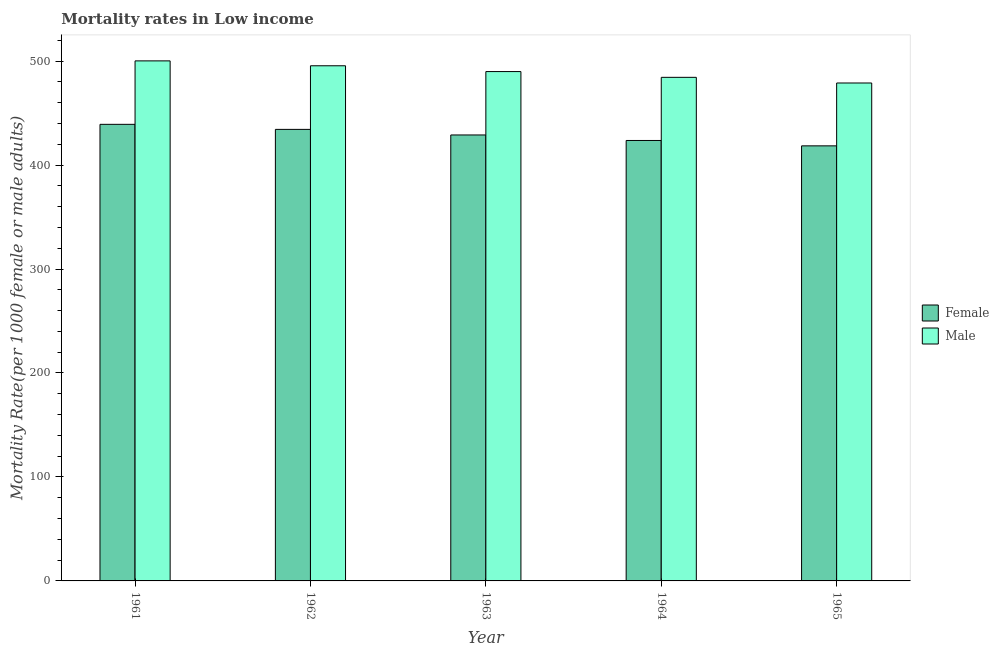How many different coloured bars are there?
Your response must be concise. 2. How many groups of bars are there?
Provide a succinct answer. 5. Are the number of bars per tick equal to the number of legend labels?
Your answer should be very brief. Yes. Are the number of bars on each tick of the X-axis equal?
Your answer should be very brief. Yes. How many bars are there on the 4th tick from the right?
Your response must be concise. 2. What is the female mortality rate in 1963?
Provide a short and direct response. 428.93. Across all years, what is the maximum male mortality rate?
Give a very brief answer. 500.19. Across all years, what is the minimum female mortality rate?
Offer a terse response. 418.46. In which year was the male mortality rate minimum?
Your response must be concise. 1965. What is the total male mortality rate in the graph?
Your answer should be compact. 2448.88. What is the difference between the male mortality rate in 1963 and that in 1964?
Make the answer very short. 5.54. What is the difference between the female mortality rate in 1963 and the male mortality rate in 1964?
Your response must be concise. 5.3. What is the average female mortality rate per year?
Offer a terse response. 428.89. In the year 1961, what is the difference between the female mortality rate and male mortality rate?
Make the answer very short. 0. In how many years, is the male mortality rate greater than 260?
Make the answer very short. 5. What is the ratio of the female mortality rate in 1961 to that in 1962?
Make the answer very short. 1.01. Is the male mortality rate in 1962 less than that in 1963?
Your answer should be very brief. No. What is the difference between the highest and the second highest male mortality rate?
Offer a terse response. 4.71. What is the difference between the highest and the lowest female mortality rate?
Offer a very short reply. 20.69. What does the 1st bar from the right in 1962 represents?
Provide a succinct answer. Male. How many bars are there?
Give a very brief answer. 10. What is the difference between two consecutive major ticks on the Y-axis?
Your response must be concise. 100. Does the graph contain grids?
Your answer should be very brief. No. How many legend labels are there?
Keep it short and to the point. 2. What is the title of the graph?
Your answer should be very brief. Mortality rates in Low income. Does "Frequency of shipment arrival" appear as one of the legend labels in the graph?
Keep it short and to the point. No. What is the label or title of the Y-axis?
Provide a short and direct response. Mortality Rate(per 1000 female or male adults). What is the Mortality Rate(per 1000 female or male adults) of Female in 1961?
Your answer should be compact. 439.15. What is the Mortality Rate(per 1000 female or male adults) of Male in 1961?
Provide a succinct answer. 500.19. What is the Mortality Rate(per 1000 female or male adults) in Female in 1962?
Provide a short and direct response. 434.3. What is the Mortality Rate(per 1000 female or male adults) in Male in 1962?
Keep it short and to the point. 495.49. What is the Mortality Rate(per 1000 female or male adults) in Female in 1963?
Keep it short and to the point. 428.93. What is the Mortality Rate(per 1000 female or male adults) of Male in 1963?
Your answer should be compact. 489.91. What is the Mortality Rate(per 1000 female or male adults) of Female in 1964?
Your response must be concise. 423.63. What is the Mortality Rate(per 1000 female or male adults) in Male in 1964?
Your answer should be very brief. 484.37. What is the Mortality Rate(per 1000 female or male adults) of Female in 1965?
Provide a succinct answer. 418.46. What is the Mortality Rate(per 1000 female or male adults) in Male in 1965?
Your answer should be compact. 478.92. Across all years, what is the maximum Mortality Rate(per 1000 female or male adults) of Female?
Your answer should be very brief. 439.15. Across all years, what is the maximum Mortality Rate(per 1000 female or male adults) of Male?
Offer a terse response. 500.19. Across all years, what is the minimum Mortality Rate(per 1000 female or male adults) in Female?
Ensure brevity in your answer.  418.46. Across all years, what is the minimum Mortality Rate(per 1000 female or male adults) of Male?
Provide a succinct answer. 478.92. What is the total Mortality Rate(per 1000 female or male adults) in Female in the graph?
Your response must be concise. 2144.47. What is the total Mortality Rate(per 1000 female or male adults) of Male in the graph?
Offer a terse response. 2448.88. What is the difference between the Mortality Rate(per 1000 female or male adults) in Female in 1961 and that in 1962?
Make the answer very short. 4.85. What is the difference between the Mortality Rate(per 1000 female or male adults) of Male in 1961 and that in 1962?
Give a very brief answer. 4.71. What is the difference between the Mortality Rate(per 1000 female or male adults) of Female in 1961 and that in 1963?
Make the answer very short. 10.22. What is the difference between the Mortality Rate(per 1000 female or male adults) of Male in 1961 and that in 1963?
Ensure brevity in your answer.  10.28. What is the difference between the Mortality Rate(per 1000 female or male adults) of Female in 1961 and that in 1964?
Provide a short and direct response. 15.52. What is the difference between the Mortality Rate(per 1000 female or male adults) of Male in 1961 and that in 1964?
Your response must be concise. 15.82. What is the difference between the Mortality Rate(per 1000 female or male adults) of Female in 1961 and that in 1965?
Make the answer very short. 20.69. What is the difference between the Mortality Rate(per 1000 female or male adults) of Male in 1961 and that in 1965?
Offer a very short reply. 21.27. What is the difference between the Mortality Rate(per 1000 female or male adults) in Female in 1962 and that in 1963?
Your answer should be compact. 5.37. What is the difference between the Mortality Rate(per 1000 female or male adults) of Male in 1962 and that in 1963?
Your answer should be compact. 5.58. What is the difference between the Mortality Rate(per 1000 female or male adults) in Female in 1962 and that in 1964?
Ensure brevity in your answer.  10.67. What is the difference between the Mortality Rate(per 1000 female or male adults) of Male in 1962 and that in 1964?
Make the answer very short. 11.12. What is the difference between the Mortality Rate(per 1000 female or male adults) in Female in 1962 and that in 1965?
Your answer should be compact. 15.84. What is the difference between the Mortality Rate(per 1000 female or male adults) of Male in 1962 and that in 1965?
Provide a short and direct response. 16.57. What is the difference between the Mortality Rate(per 1000 female or male adults) in Female in 1963 and that in 1964?
Keep it short and to the point. 5.3. What is the difference between the Mortality Rate(per 1000 female or male adults) of Male in 1963 and that in 1964?
Ensure brevity in your answer.  5.54. What is the difference between the Mortality Rate(per 1000 female or male adults) of Female in 1963 and that in 1965?
Give a very brief answer. 10.48. What is the difference between the Mortality Rate(per 1000 female or male adults) in Male in 1963 and that in 1965?
Keep it short and to the point. 10.99. What is the difference between the Mortality Rate(per 1000 female or male adults) in Female in 1964 and that in 1965?
Your answer should be compact. 5.17. What is the difference between the Mortality Rate(per 1000 female or male adults) in Male in 1964 and that in 1965?
Your response must be concise. 5.45. What is the difference between the Mortality Rate(per 1000 female or male adults) in Female in 1961 and the Mortality Rate(per 1000 female or male adults) in Male in 1962?
Your answer should be very brief. -56.33. What is the difference between the Mortality Rate(per 1000 female or male adults) in Female in 1961 and the Mortality Rate(per 1000 female or male adults) in Male in 1963?
Offer a terse response. -50.76. What is the difference between the Mortality Rate(per 1000 female or male adults) of Female in 1961 and the Mortality Rate(per 1000 female or male adults) of Male in 1964?
Give a very brief answer. -45.22. What is the difference between the Mortality Rate(per 1000 female or male adults) in Female in 1961 and the Mortality Rate(per 1000 female or male adults) in Male in 1965?
Offer a terse response. -39.77. What is the difference between the Mortality Rate(per 1000 female or male adults) of Female in 1962 and the Mortality Rate(per 1000 female or male adults) of Male in 1963?
Offer a terse response. -55.61. What is the difference between the Mortality Rate(per 1000 female or male adults) in Female in 1962 and the Mortality Rate(per 1000 female or male adults) in Male in 1964?
Offer a terse response. -50.07. What is the difference between the Mortality Rate(per 1000 female or male adults) in Female in 1962 and the Mortality Rate(per 1000 female or male adults) in Male in 1965?
Offer a terse response. -44.62. What is the difference between the Mortality Rate(per 1000 female or male adults) in Female in 1963 and the Mortality Rate(per 1000 female or male adults) in Male in 1964?
Offer a terse response. -55.44. What is the difference between the Mortality Rate(per 1000 female or male adults) of Female in 1963 and the Mortality Rate(per 1000 female or male adults) of Male in 1965?
Your response must be concise. -49.99. What is the difference between the Mortality Rate(per 1000 female or male adults) of Female in 1964 and the Mortality Rate(per 1000 female or male adults) of Male in 1965?
Give a very brief answer. -55.29. What is the average Mortality Rate(per 1000 female or male adults) in Female per year?
Your answer should be very brief. 428.89. What is the average Mortality Rate(per 1000 female or male adults) in Male per year?
Keep it short and to the point. 489.78. In the year 1961, what is the difference between the Mortality Rate(per 1000 female or male adults) of Female and Mortality Rate(per 1000 female or male adults) of Male?
Ensure brevity in your answer.  -61.04. In the year 1962, what is the difference between the Mortality Rate(per 1000 female or male adults) of Female and Mortality Rate(per 1000 female or male adults) of Male?
Provide a short and direct response. -61.18. In the year 1963, what is the difference between the Mortality Rate(per 1000 female or male adults) in Female and Mortality Rate(per 1000 female or male adults) in Male?
Provide a succinct answer. -60.98. In the year 1964, what is the difference between the Mortality Rate(per 1000 female or male adults) in Female and Mortality Rate(per 1000 female or male adults) in Male?
Your response must be concise. -60.74. In the year 1965, what is the difference between the Mortality Rate(per 1000 female or male adults) in Female and Mortality Rate(per 1000 female or male adults) in Male?
Offer a very short reply. -60.46. What is the ratio of the Mortality Rate(per 1000 female or male adults) in Female in 1961 to that in 1962?
Ensure brevity in your answer.  1.01. What is the ratio of the Mortality Rate(per 1000 female or male adults) in Male in 1961 to that in 1962?
Provide a short and direct response. 1.01. What is the ratio of the Mortality Rate(per 1000 female or male adults) of Female in 1961 to that in 1963?
Give a very brief answer. 1.02. What is the ratio of the Mortality Rate(per 1000 female or male adults) in Female in 1961 to that in 1964?
Ensure brevity in your answer.  1.04. What is the ratio of the Mortality Rate(per 1000 female or male adults) in Male in 1961 to that in 1964?
Your answer should be compact. 1.03. What is the ratio of the Mortality Rate(per 1000 female or male adults) in Female in 1961 to that in 1965?
Provide a short and direct response. 1.05. What is the ratio of the Mortality Rate(per 1000 female or male adults) of Male in 1961 to that in 1965?
Make the answer very short. 1.04. What is the ratio of the Mortality Rate(per 1000 female or male adults) in Female in 1962 to that in 1963?
Provide a succinct answer. 1.01. What is the ratio of the Mortality Rate(per 1000 female or male adults) in Male in 1962 to that in 1963?
Provide a short and direct response. 1.01. What is the ratio of the Mortality Rate(per 1000 female or male adults) of Female in 1962 to that in 1964?
Provide a succinct answer. 1.03. What is the ratio of the Mortality Rate(per 1000 female or male adults) of Male in 1962 to that in 1964?
Your answer should be very brief. 1.02. What is the ratio of the Mortality Rate(per 1000 female or male adults) in Female in 1962 to that in 1965?
Offer a very short reply. 1.04. What is the ratio of the Mortality Rate(per 1000 female or male adults) in Male in 1962 to that in 1965?
Ensure brevity in your answer.  1.03. What is the ratio of the Mortality Rate(per 1000 female or male adults) in Female in 1963 to that in 1964?
Ensure brevity in your answer.  1.01. What is the ratio of the Mortality Rate(per 1000 female or male adults) in Male in 1963 to that in 1964?
Provide a short and direct response. 1.01. What is the ratio of the Mortality Rate(per 1000 female or male adults) in Female in 1963 to that in 1965?
Ensure brevity in your answer.  1.02. What is the ratio of the Mortality Rate(per 1000 female or male adults) of Male in 1963 to that in 1965?
Provide a succinct answer. 1.02. What is the ratio of the Mortality Rate(per 1000 female or male adults) of Female in 1964 to that in 1965?
Your response must be concise. 1.01. What is the ratio of the Mortality Rate(per 1000 female or male adults) of Male in 1964 to that in 1965?
Your response must be concise. 1.01. What is the difference between the highest and the second highest Mortality Rate(per 1000 female or male adults) of Female?
Offer a very short reply. 4.85. What is the difference between the highest and the second highest Mortality Rate(per 1000 female or male adults) of Male?
Your answer should be compact. 4.71. What is the difference between the highest and the lowest Mortality Rate(per 1000 female or male adults) in Female?
Ensure brevity in your answer.  20.69. What is the difference between the highest and the lowest Mortality Rate(per 1000 female or male adults) of Male?
Your response must be concise. 21.27. 